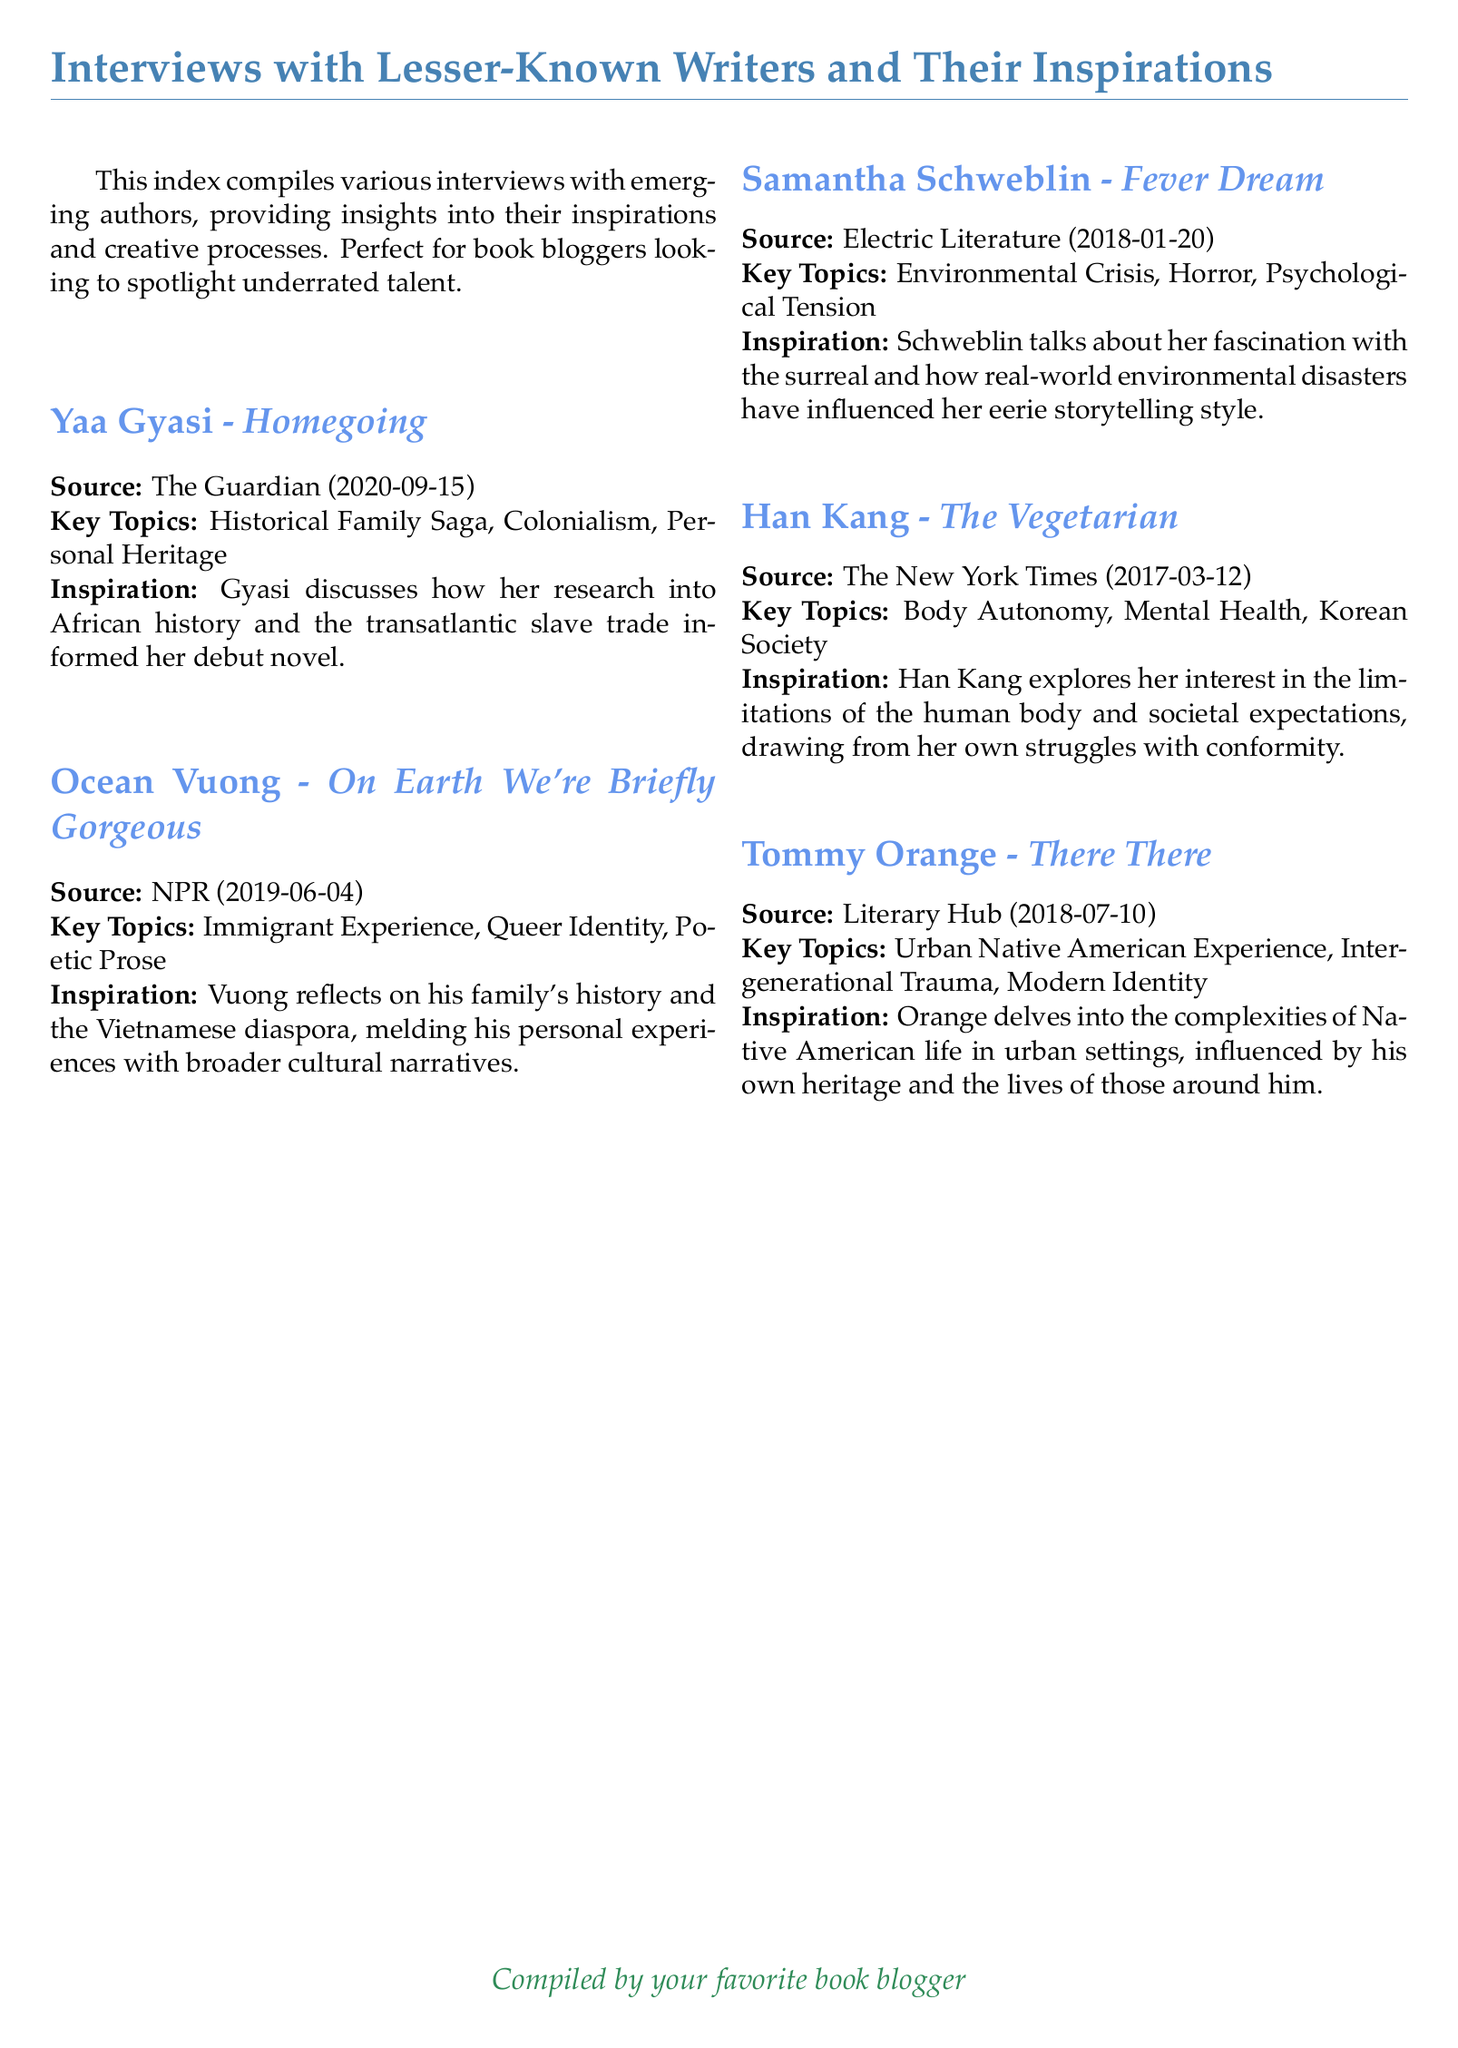What is the title of Yaa Gyasi's book? The title of Yaa Gyasi's book is featured under her interview section.
Answer: Homegoing When was the interview with Ocean Vuong published? The document states the publication date of Ocean Vuong's interview.
Answer: 2019-06-04 Which key topics are discussed in Han Kang's interview? The document lists the key topics associated with Han Kang's work.
Answer: Body Autonomy, Mental Health, Korean Society Who compiled this index? The document indicates the person responsible for compiling the interviews.
Answer: your favorite book blogger What is the primary theme of Tommy Orange's book? The document summarizes the primary focus of Tommy Orange's literary work.
Answer: Urban Native American Experience What inspired Samantha Schweblin's writing? The document explains the inspiration that led to Schweblin's writing style.
Answer: real-world environmental disasters How many interviews are featured in this index? The document lists the interviews included in the index.
Answer: Five What publication featured Yaa Gyasi's interview? The document specifies the source of Yaa Gyasi's interview.
Answer: The Guardian What commonality do all the authors in this document share? The document features authors who are described in a specific context.
Answer: They are lesser-known writers 